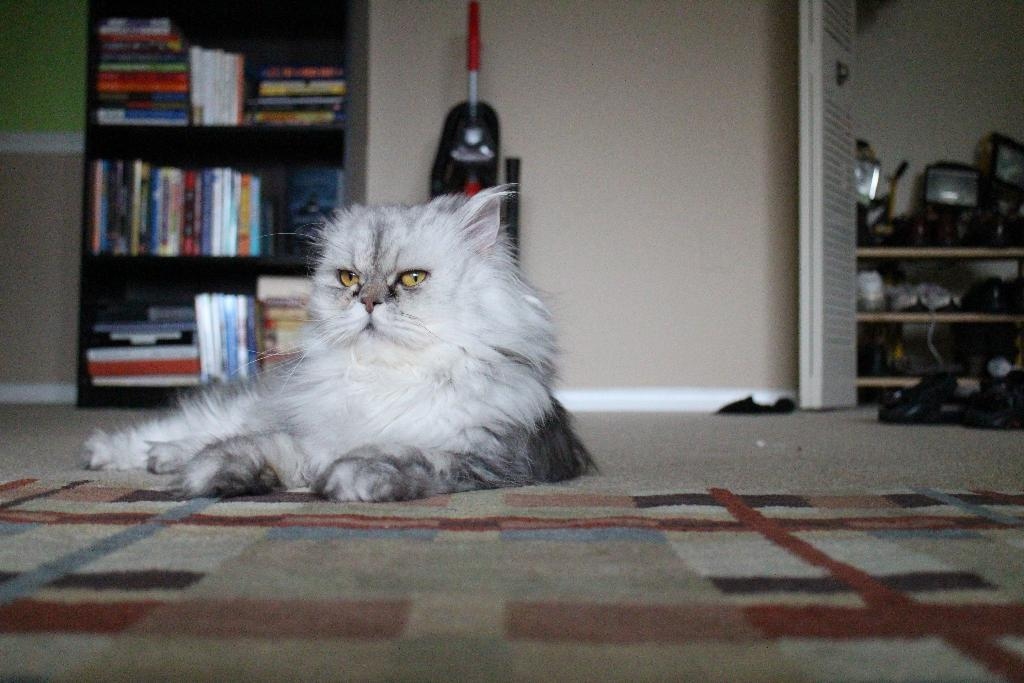What type of animal can be seen in the image? There is a cat in the image. What can be found on the shelves in the image? The shelves in the image contain objects, including books. Can you describe the ground in the image? The ground is visible in the image, and there are objects on it. What architectural features are present in the image? There is a wall and a door in the image. Is the cat playing basketball in the image? No, there is no basketball present in the image, and the cat is not engaged in any basketball-related activity. 